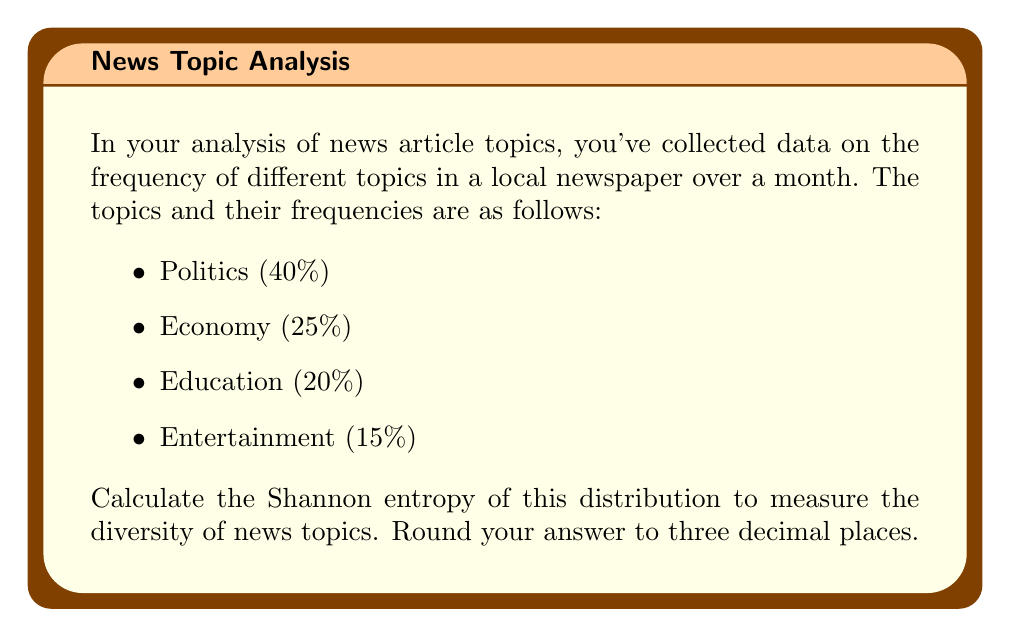Help me with this question. To calculate the Shannon entropy, we'll use the formula:

$$H = -\sum_{i=1}^{n} p_i \log_2(p_i)$$

Where:
- $H$ is the Shannon entropy
- $p_i$ is the probability of each topic
- $n$ is the number of topics

Let's calculate for each topic:

1. Politics: $p_1 = 0.40$
   $-0.40 \log_2(0.40) = 0.528771356$

2. Economy: $p_2 = 0.25$
   $-0.25 \log_2(0.25) = 0.5$

3. Education: $p_3 = 0.20$
   $-0.20 \log_2(0.20) = 0.464385619$

4. Entertainment: $p_4 = 0.15$
   $-0.15 \log_2(0.15) = 0.410239336$

Now, sum all these values:

$$H = 0.528771356 + 0.5 + 0.464385619 + 0.410239336 = 1.903396311$$

Rounding to three decimal places, we get 1.903.

This value represents the average amount of information contained in the news topic distribution. A higher value indicates more diversity in topics, while a lower value suggests less diversity.
Answer: 1.903 bits 